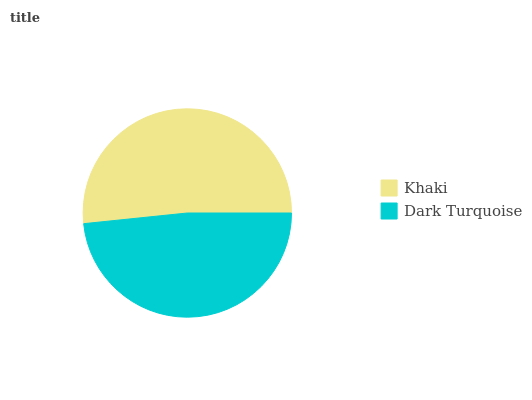Is Dark Turquoise the minimum?
Answer yes or no. Yes. Is Khaki the maximum?
Answer yes or no. Yes. Is Dark Turquoise the maximum?
Answer yes or no. No. Is Khaki greater than Dark Turquoise?
Answer yes or no. Yes. Is Dark Turquoise less than Khaki?
Answer yes or no. Yes. Is Dark Turquoise greater than Khaki?
Answer yes or no. No. Is Khaki less than Dark Turquoise?
Answer yes or no. No. Is Khaki the high median?
Answer yes or no. Yes. Is Dark Turquoise the low median?
Answer yes or no. Yes. Is Dark Turquoise the high median?
Answer yes or no. No. Is Khaki the low median?
Answer yes or no. No. 